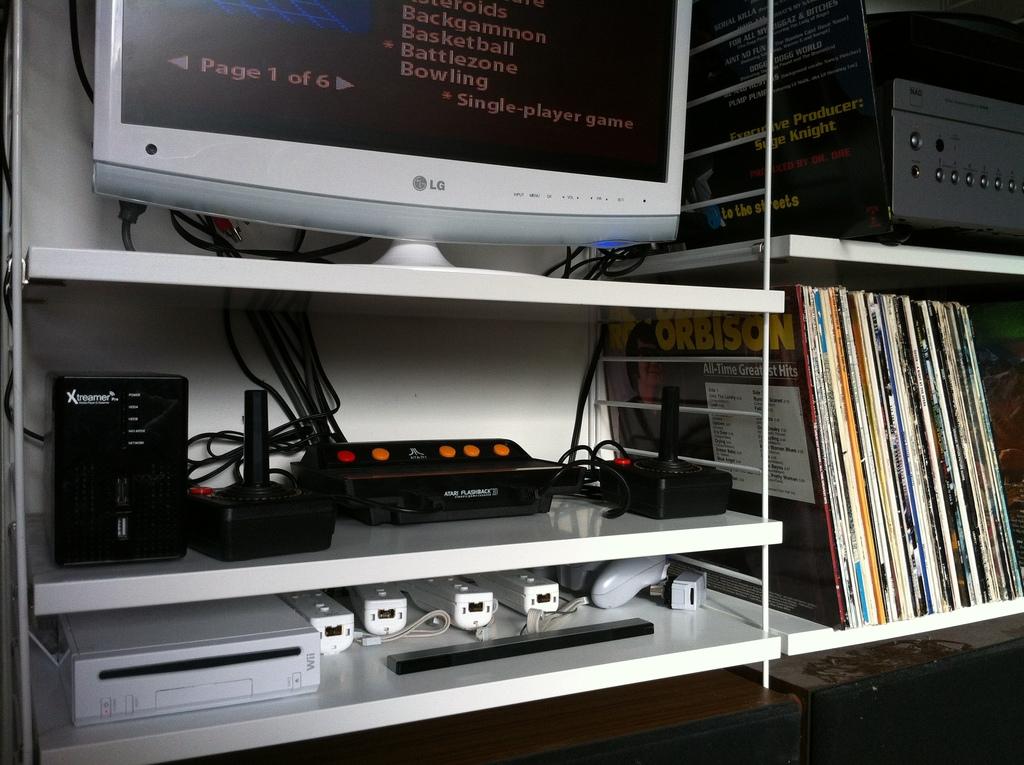Who makes the monitor?
Offer a very short reply. Lg. 